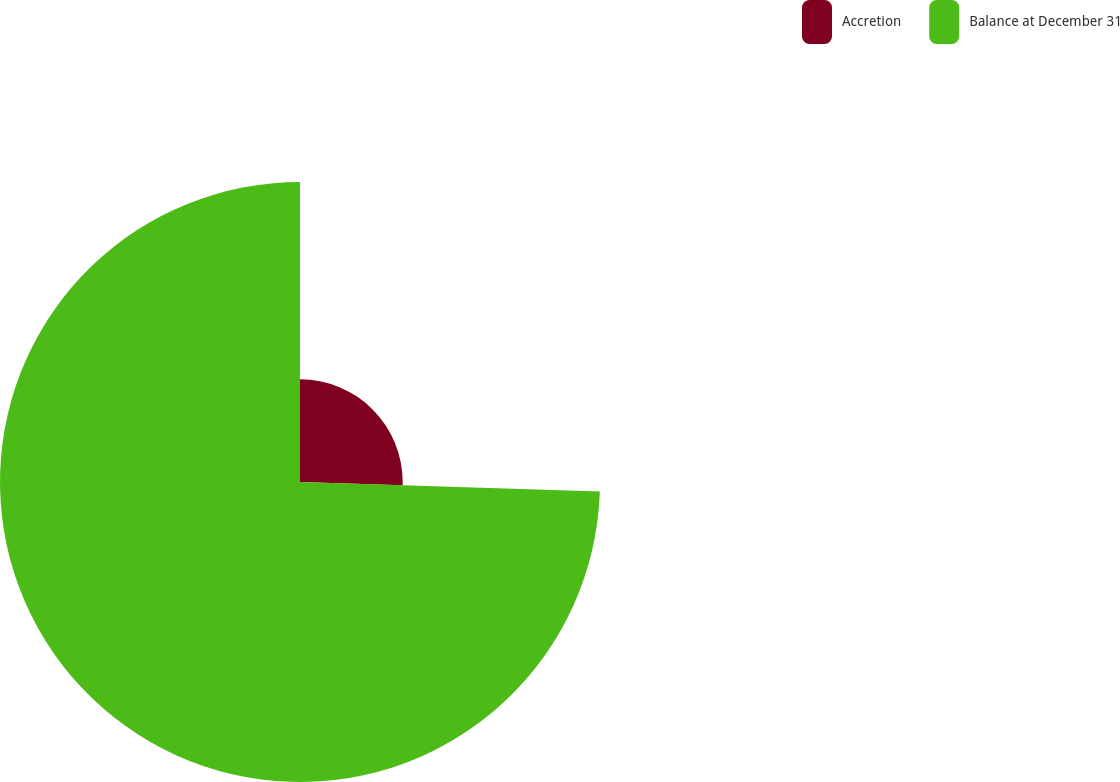Convert chart to OTSL. <chart><loc_0><loc_0><loc_500><loc_500><pie_chart><fcel>Accretion<fcel>Balance at December 31<nl><fcel>25.5%<fcel>74.5%<nl></chart> 